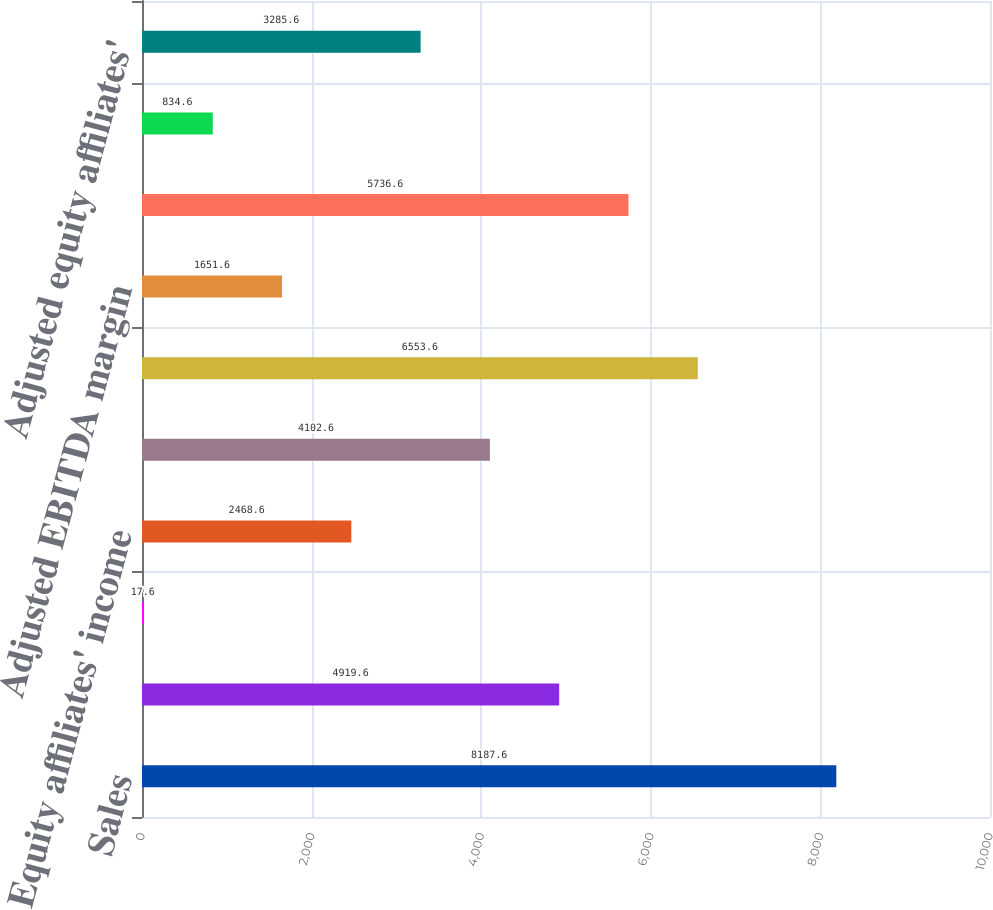Convert chart. <chart><loc_0><loc_0><loc_500><loc_500><bar_chart><fcel>Sales<fcel>Operating income<fcel>Operating margin<fcel>Equity affiliates' income<fcel>Income from continuing<fcel>Adjusted EBITDA<fcel>Adjusted EBITDA margin<fcel>Adjusted operating income<fcel>Adjusted operating margin<fcel>Adjusted equity affiliates'<nl><fcel>8187.6<fcel>4919.6<fcel>17.6<fcel>2468.6<fcel>4102.6<fcel>6553.6<fcel>1651.6<fcel>5736.6<fcel>834.6<fcel>3285.6<nl></chart> 